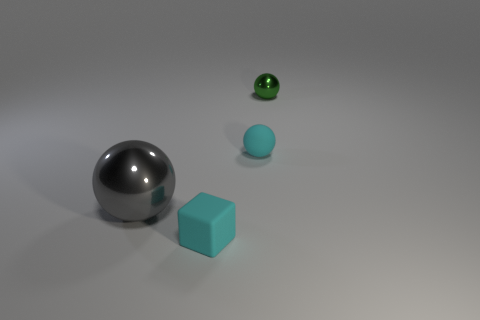Add 3 cyan matte spheres. How many objects exist? 7 Subtract all blocks. How many objects are left? 3 Add 3 green balls. How many green balls are left? 4 Add 1 cyan rubber blocks. How many cyan rubber blocks exist? 2 Subtract 1 gray balls. How many objects are left? 3 Subtract all gray blocks. Subtract all small green shiny objects. How many objects are left? 3 